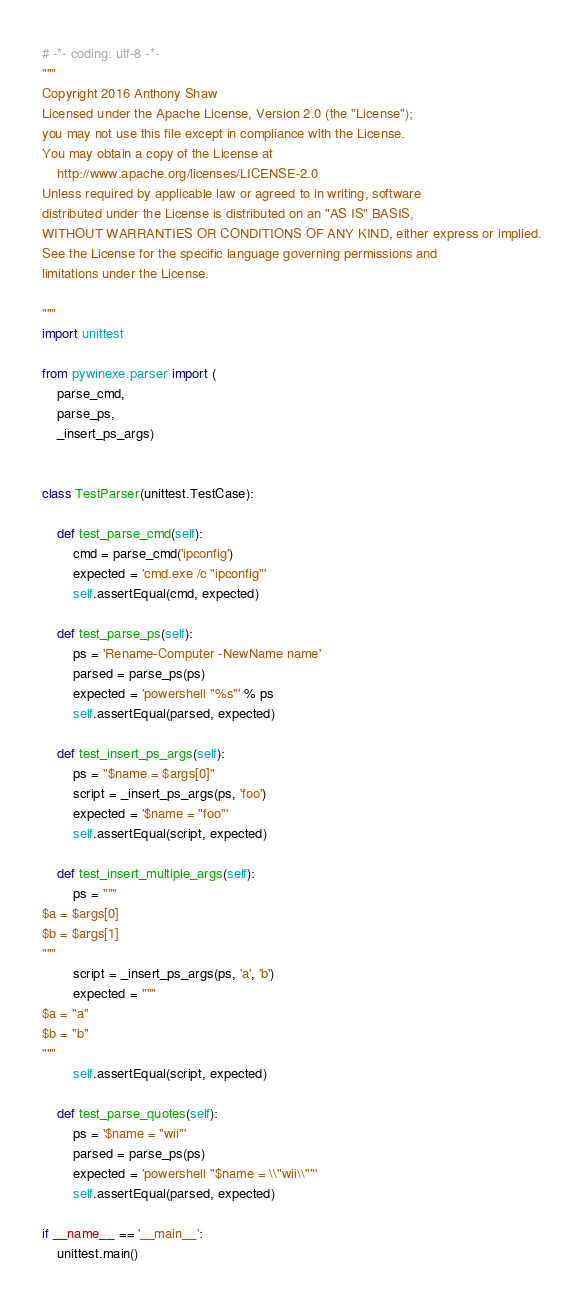Convert code to text. <code><loc_0><loc_0><loc_500><loc_500><_Python_># -*- coding: utf-8 -*-
"""
Copyright 2016 Anthony Shaw
Licensed under the Apache License, Version 2.0 (the "License");
you may not use this file except in compliance with the License.
You may obtain a copy of the License at
    http://www.apache.org/licenses/LICENSE-2.0
Unless required by applicable law or agreed to in writing, software
distributed under the License is distributed on an "AS IS" BASIS,
WITHOUT WARRANTIES OR CONDITIONS OF ANY KIND, either express or implied.
See the License for the specific language governing permissions and
limitations under the License.

"""
import unittest

from pywinexe.parser import (
    parse_cmd,
    parse_ps,
    _insert_ps_args)


class TestParser(unittest.TestCase):

    def test_parse_cmd(self):
        cmd = parse_cmd('ipconfig')
        expected = 'cmd.exe /c "ipconfig"'
        self.assertEqual(cmd, expected)

    def test_parse_ps(self):
        ps = 'Rename-Computer -NewName name'
        parsed = parse_ps(ps)
        expected = 'powershell "%s"' % ps
        self.assertEqual(parsed, expected)

    def test_insert_ps_args(self):
        ps = "$name = $args[0]"
        script = _insert_ps_args(ps, 'foo')
        expected = '$name = "foo"'
        self.assertEqual(script, expected)

    def test_insert_multiple_args(self):
        ps = """
$a = $args[0]
$b = $args[1]
"""
        script = _insert_ps_args(ps, 'a', 'b')
        expected = """
$a = "a"
$b = "b"
"""
        self.assertEqual(script, expected)

    def test_parse_quotes(self):
        ps = '$name = "wii"'
        parsed = parse_ps(ps)
        expected = 'powershell "$name = \\"wii\\""'
        self.assertEqual(parsed, expected)

if __name__ == '__main__':
    unittest.main()
</code> 